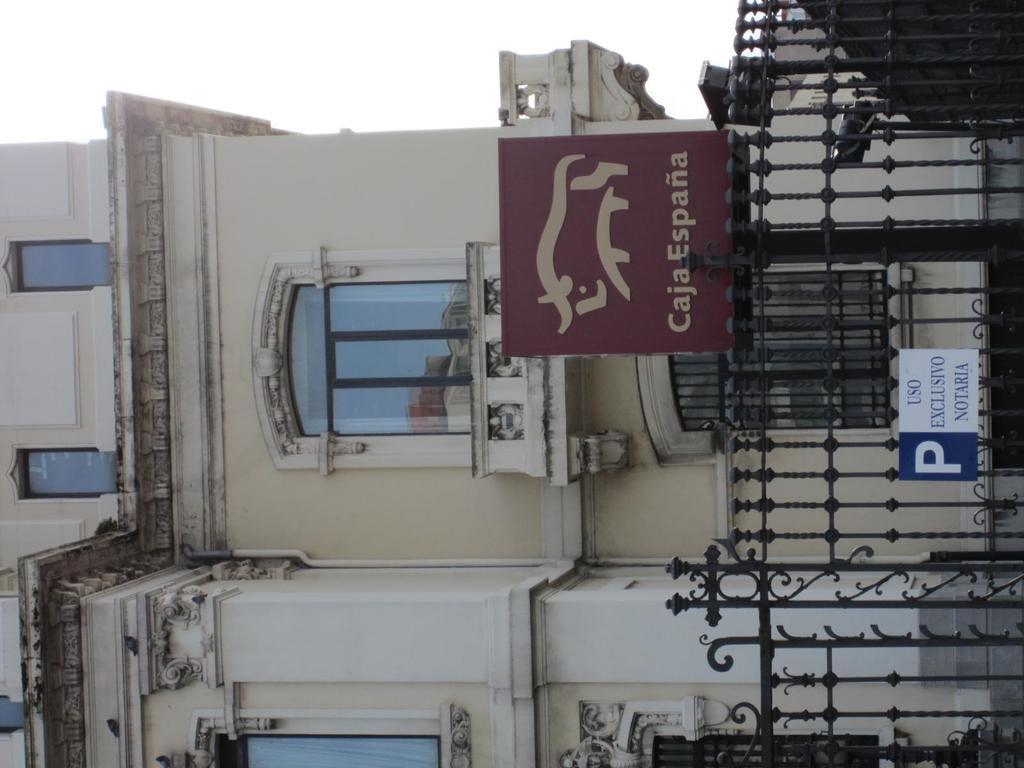Please provide a concise description of this image. Here in this picture we can see a building with windows on it present and in the front we can see a railing present and on that we can see a hoarding and a board present and we can see the sky is clear. 